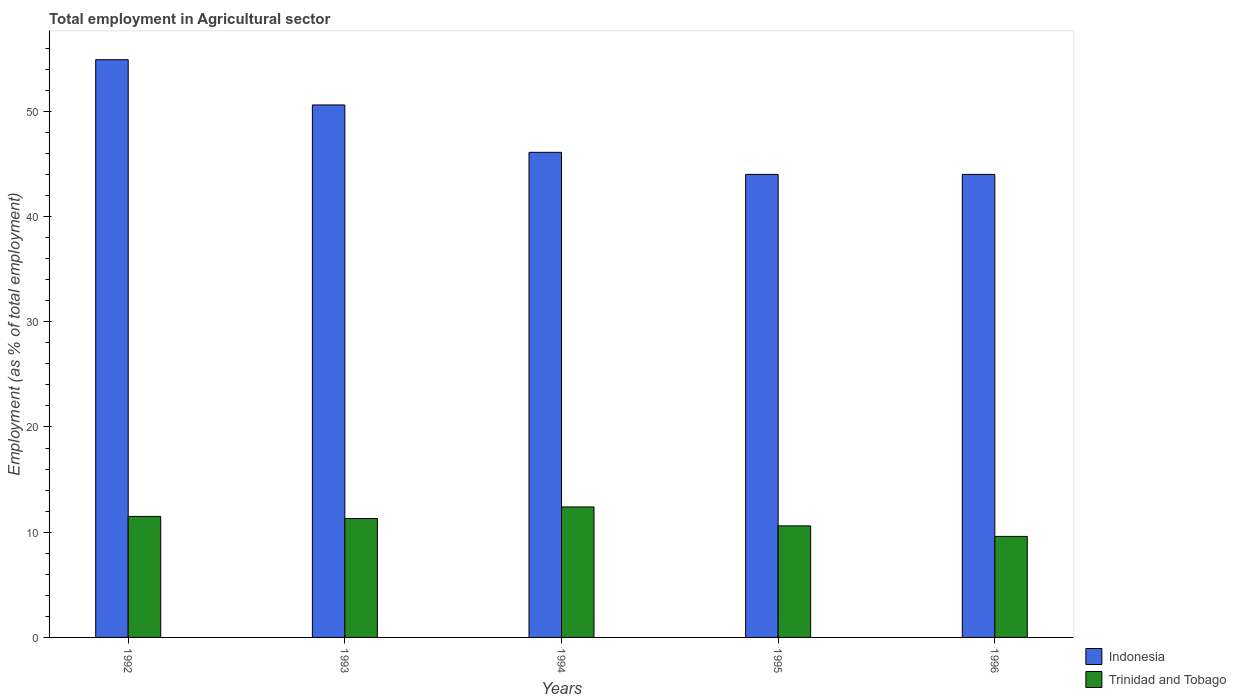Are the number of bars per tick equal to the number of legend labels?
Provide a succinct answer. Yes. Are the number of bars on each tick of the X-axis equal?
Your answer should be very brief. Yes. How many bars are there on the 1st tick from the left?
Offer a terse response. 2. How many bars are there on the 1st tick from the right?
Offer a very short reply. 2. What is the label of the 1st group of bars from the left?
Your answer should be compact. 1992. In how many cases, is the number of bars for a given year not equal to the number of legend labels?
Provide a succinct answer. 0. What is the employment in agricultural sector in Indonesia in 1992?
Your answer should be very brief. 54.9. Across all years, what is the maximum employment in agricultural sector in Indonesia?
Offer a very short reply. 54.9. Across all years, what is the minimum employment in agricultural sector in Trinidad and Tobago?
Offer a terse response. 9.6. What is the total employment in agricultural sector in Trinidad and Tobago in the graph?
Your answer should be compact. 55.4. What is the difference between the employment in agricultural sector in Trinidad and Tobago in 1993 and that in 1996?
Your answer should be very brief. 1.7. What is the difference between the employment in agricultural sector in Trinidad and Tobago in 1994 and the employment in agricultural sector in Indonesia in 1995?
Your answer should be compact. -31.6. What is the average employment in agricultural sector in Trinidad and Tobago per year?
Your answer should be very brief. 11.08. In the year 1996, what is the difference between the employment in agricultural sector in Indonesia and employment in agricultural sector in Trinidad and Tobago?
Make the answer very short. 34.4. What is the ratio of the employment in agricultural sector in Indonesia in 1992 to that in 1996?
Offer a terse response. 1.25. Is the employment in agricultural sector in Trinidad and Tobago in 1992 less than that in 1994?
Your answer should be compact. Yes. What is the difference between the highest and the second highest employment in agricultural sector in Trinidad and Tobago?
Ensure brevity in your answer.  0.9. What is the difference between the highest and the lowest employment in agricultural sector in Indonesia?
Ensure brevity in your answer.  10.9. In how many years, is the employment in agricultural sector in Indonesia greater than the average employment in agricultural sector in Indonesia taken over all years?
Offer a terse response. 2. Is the sum of the employment in agricultural sector in Indonesia in 1994 and 1995 greater than the maximum employment in agricultural sector in Trinidad and Tobago across all years?
Your answer should be compact. Yes. What does the 2nd bar from the left in 1992 represents?
Your response must be concise. Trinidad and Tobago. What does the 2nd bar from the right in 1994 represents?
Your answer should be very brief. Indonesia. How many bars are there?
Provide a short and direct response. 10. Are the values on the major ticks of Y-axis written in scientific E-notation?
Your response must be concise. No. How many legend labels are there?
Your answer should be compact. 2. How are the legend labels stacked?
Provide a succinct answer. Vertical. What is the title of the graph?
Provide a short and direct response. Total employment in Agricultural sector. What is the label or title of the X-axis?
Offer a very short reply. Years. What is the label or title of the Y-axis?
Your response must be concise. Employment (as % of total employment). What is the Employment (as % of total employment) of Indonesia in 1992?
Offer a terse response. 54.9. What is the Employment (as % of total employment) of Indonesia in 1993?
Offer a very short reply. 50.6. What is the Employment (as % of total employment) of Trinidad and Tobago in 1993?
Give a very brief answer. 11.3. What is the Employment (as % of total employment) of Indonesia in 1994?
Give a very brief answer. 46.1. What is the Employment (as % of total employment) of Trinidad and Tobago in 1994?
Provide a succinct answer. 12.4. What is the Employment (as % of total employment) in Trinidad and Tobago in 1995?
Your answer should be compact. 10.6. What is the Employment (as % of total employment) in Trinidad and Tobago in 1996?
Ensure brevity in your answer.  9.6. Across all years, what is the maximum Employment (as % of total employment) in Indonesia?
Offer a very short reply. 54.9. Across all years, what is the maximum Employment (as % of total employment) in Trinidad and Tobago?
Provide a succinct answer. 12.4. Across all years, what is the minimum Employment (as % of total employment) in Trinidad and Tobago?
Provide a short and direct response. 9.6. What is the total Employment (as % of total employment) in Indonesia in the graph?
Offer a very short reply. 239.6. What is the total Employment (as % of total employment) of Trinidad and Tobago in the graph?
Provide a short and direct response. 55.4. What is the difference between the Employment (as % of total employment) of Indonesia in 1992 and that in 1993?
Provide a short and direct response. 4.3. What is the difference between the Employment (as % of total employment) in Trinidad and Tobago in 1992 and that in 1993?
Your answer should be very brief. 0.2. What is the difference between the Employment (as % of total employment) of Indonesia in 1992 and that in 1995?
Your answer should be very brief. 10.9. What is the difference between the Employment (as % of total employment) of Trinidad and Tobago in 1992 and that in 1995?
Offer a very short reply. 0.9. What is the difference between the Employment (as % of total employment) of Indonesia in 1992 and that in 1996?
Give a very brief answer. 10.9. What is the difference between the Employment (as % of total employment) of Trinidad and Tobago in 1992 and that in 1996?
Ensure brevity in your answer.  1.9. What is the difference between the Employment (as % of total employment) of Trinidad and Tobago in 1993 and that in 1995?
Your response must be concise. 0.7. What is the difference between the Employment (as % of total employment) of Indonesia in 1994 and that in 1995?
Keep it short and to the point. 2.1. What is the difference between the Employment (as % of total employment) of Trinidad and Tobago in 1994 and that in 1996?
Keep it short and to the point. 2.8. What is the difference between the Employment (as % of total employment) of Indonesia in 1992 and the Employment (as % of total employment) of Trinidad and Tobago in 1993?
Provide a short and direct response. 43.6. What is the difference between the Employment (as % of total employment) of Indonesia in 1992 and the Employment (as % of total employment) of Trinidad and Tobago in 1994?
Your answer should be compact. 42.5. What is the difference between the Employment (as % of total employment) of Indonesia in 1992 and the Employment (as % of total employment) of Trinidad and Tobago in 1995?
Your answer should be compact. 44.3. What is the difference between the Employment (as % of total employment) in Indonesia in 1992 and the Employment (as % of total employment) in Trinidad and Tobago in 1996?
Offer a very short reply. 45.3. What is the difference between the Employment (as % of total employment) in Indonesia in 1993 and the Employment (as % of total employment) in Trinidad and Tobago in 1994?
Your answer should be compact. 38.2. What is the difference between the Employment (as % of total employment) in Indonesia in 1993 and the Employment (as % of total employment) in Trinidad and Tobago in 1995?
Your response must be concise. 40. What is the difference between the Employment (as % of total employment) in Indonesia in 1993 and the Employment (as % of total employment) in Trinidad and Tobago in 1996?
Your response must be concise. 41. What is the difference between the Employment (as % of total employment) in Indonesia in 1994 and the Employment (as % of total employment) in Trinidad and Tobago in 1995?
Your answer should be compact. 35.5. What is the difference between the Employment (as % of total employment) of Indonesia in 1994 and the Employment (as % of total employment) of Trinidad and Tobago in 1996?
Offer a terse response. 36.5. What is the difference between the Employment (as % of total employment) of Indonesia in 1995 and the Employment (as % of total employment) of Trinidad and Tobago in 1996?
Provide a succinct answer. 34.4. What is the average Employment (as % of total employment) in Indonesia per year?
Provide a short and direct response. 47.92. What is the average Employment (as % of total employment) of Trinidad and Tobago per year?
Ensure brevity in your answer.  11.08. In the year 1992, what is the difference between the Employment (as % of total employment) in Indonesia and Employment (as % of total employment) in Trinidad and Tobago?
Keep it short and to the point. 43.4. In the year 1993, what is the difference between the Employment (as % of total employment) in Indonesia and Employment (as % of total employment) in Trinidad and Tobago?
Your response must be concise. 39.3. In the year 1994, what is the difference between the Employment (as % of total employment) in Indonesia and Employment (as % of total employment) in Trinidad and Tobago?
Provide a short and direct response. 33.7. In the year 1995, what is the difference between the Employment (as % of total employment) in Indonesia and Employment (as % of total employment) in Trinidad and Tobago?
Your response must be concise. 33.4. In the year 1996, what is the difference between the Employment (as % of total employment) in Indonesia and Employment (as % of total employment) in Trinidad and Tobago?
Ensure brevity in your answer.  34.4. What is the ratio of the Employment (as % of total employment) of Indonesia in 1992 to that in 1993?
Ensure brevity in your answer.  1.08. What is the ratio of the Employment (as % of total employment) in Trinidad and Tobago in 1992 to that in 1993?
Your answer should be very brief. 1.02. What is the ratio of the Employment (as % of total employment) in Indonesia in 1992 to that in 1994?
Your answer should be very brief. 1.19. What is the ratio of the Employment (as % of total employment) in Trinidad and Tobago in 1992 to that in 1994?
Offer a very short reply. 0.93. What is the ratio of the Employment (as % of total employment) of Indonesia in 1992 to that in 1995?
Give a very brief answer. 1.25. What is the ratio of the Employment (as % of total employment) of Trinidad and Tobago in 1992 to that in 1995?
Your answer should be very brief. 1.08. What is the ratio of the Employment (as % of total employment) of Indonesia in 1992 to that in 1996?
Provide a succinct answer. 1.25. What is the ratio of the Employment (as % of total employment) of Trinidad and Tobago in 1992 to that in 1996?
Offer a very short reply. 1.2. What is the ratio of the Employment (as % of total employment) of Indonesia in 1993 to that in 1994?
Your answer should be very brief. 1.1. What is the ratio of the Employment (as % of total employment) of Trinidad and Tobago in 1993 to that in 1994?
Your answer should be compact. 0.91. What is the ratio of the Employment (as % of total employment) in Indonesia in 1993 to that in 1995?
Keep it short and to the point. 1.15. What is the ratio of the Employment (as % of total employment) of Trinidad and Tobago in 1993 to that in 1995?
Offer a terse response. 1.07. What is the ratio of the Employment (as % of total employment) in Indonesia in 1993 to that in 1996?
Your answer should be very brief. 1.15. What is the ratio of the Employment (as % of total employment) of Trinidad and Tobago in 1993 to that in 1996?
Your answer should be compact. 1.18. What is the ratio of the Employment (as % of total employment) in Indonesia in 1994 to that in 1995?
Offer a very short reply. 1.05. What is the ratio of the Employment (as % of total employment) of Trinidad and Tobago in 1994 to that in 1995?
Offer a very short reply. 1.17. What is the ratio of the Employment (as % of total employment) of Indonesia in 1994 to that in 1996?
Make the answer very short. 1.05. What is the ratio of the Employment (as % of total employment) in Trinidad and Tobago in 1994 to that in 1996?
Your response must be concise. 1.29. What is the ratio of the Employment (as % of total employment) of Indonesia in 1995 to that in 1996?
Keep it short and to the point. 1. What is the ratio of the Employment (as % of total employment) in Trinidad and Tobago in 1995 to that in 1996?
Your response must be concise. 1.1. What is the difference between the highest and the second highest Employment (as % of total employment) of Trinidad and Tobago?
Keep it short and to the point. 0.9. What is the difference between the highest and the lowest Employment (as % of total employment) in Indonesia?
Make the answer very short. 10.9. What is the difference between the highest and the lowest Employment (as % of total employment) in Trinidad and Tobago?
Give a very brief answer. 2.8. 